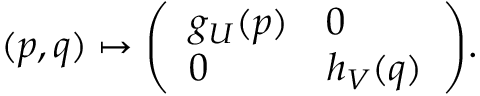Convert formula to latex. <formula><loc_0><loc_0><loc_500><loc_500>( p , q ) \mapsto { \left ( \begin{array} { l l } { g _ { U } ( p ) } & { 0 } \\ { 0 } & { h _ { V } ( q ) } \end{array} \right ) } .</formula> 